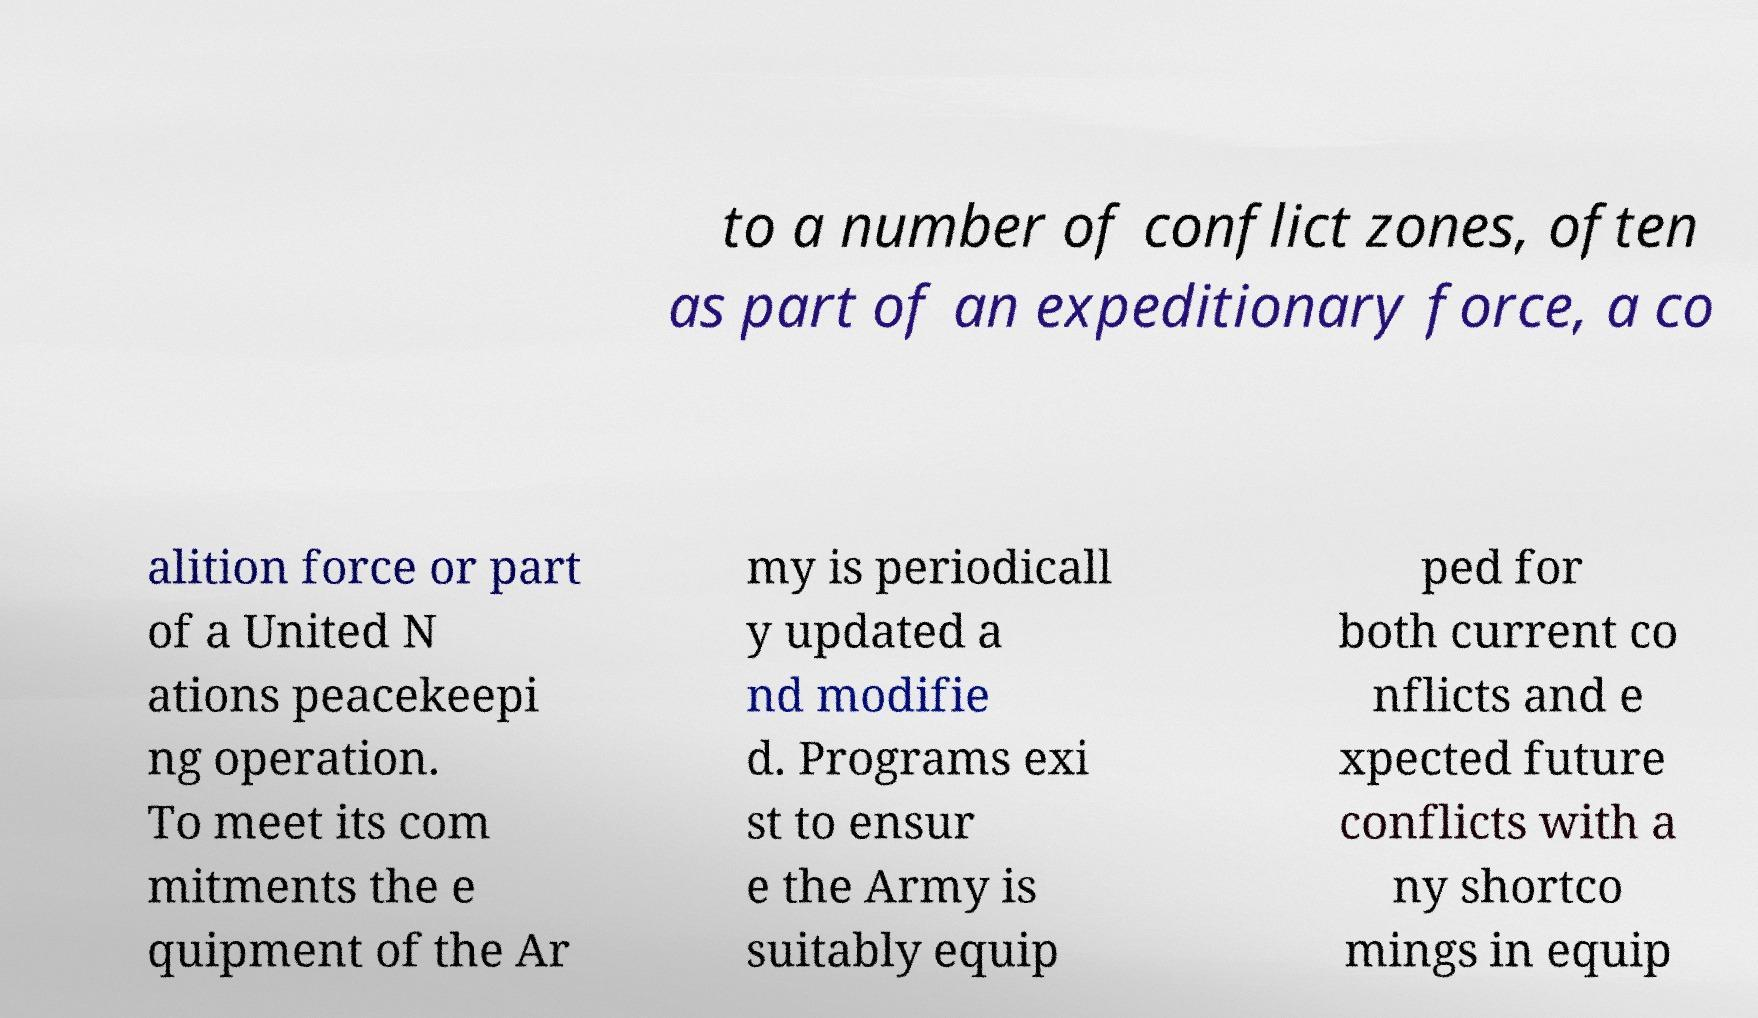Please identify and transcribe the text found in this image. to a number of conflict zones, often as part of an expeditionary force, a co alition force or part of a United N ations peacekeepi ng operation. To meet its com mitments the e quipment of the Ar my is periodicall y updated a nd modifie d. Programs exi st to ensur e the Army is suitably equip ped for both current co nflicts and e xpected future conflicts with a ny shortco mings in equip 